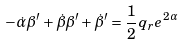Convert formula to latex. <formula><loc_0><loc_0><loc_500><loc_500>- \dot { \alpha } \beta ^ { \prime } + \dot { \beta } \beta ^ { \prime } + \dot { \beta } ^ { \prime } = \frac { 1 } { 2 } q _ { r } e ^ { 2 \alpha }</formula> 